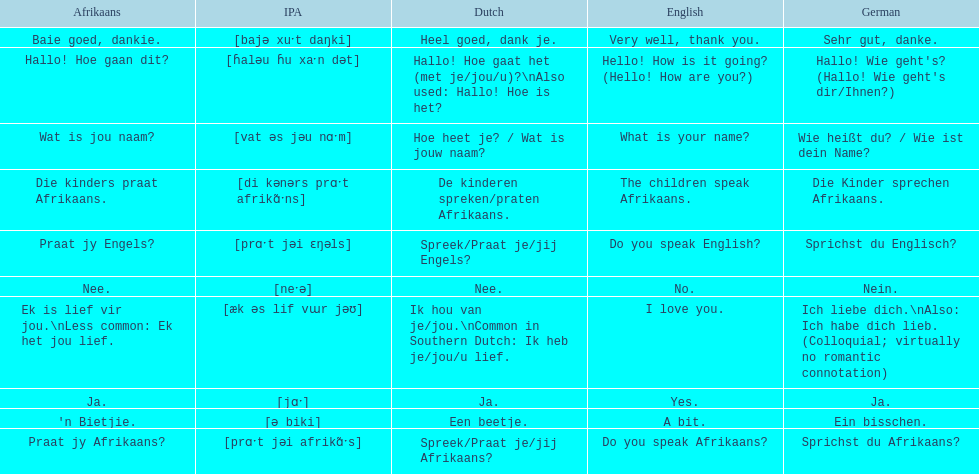How do you say 'i love you' in afrikaans? Ek is lief vir jou. 